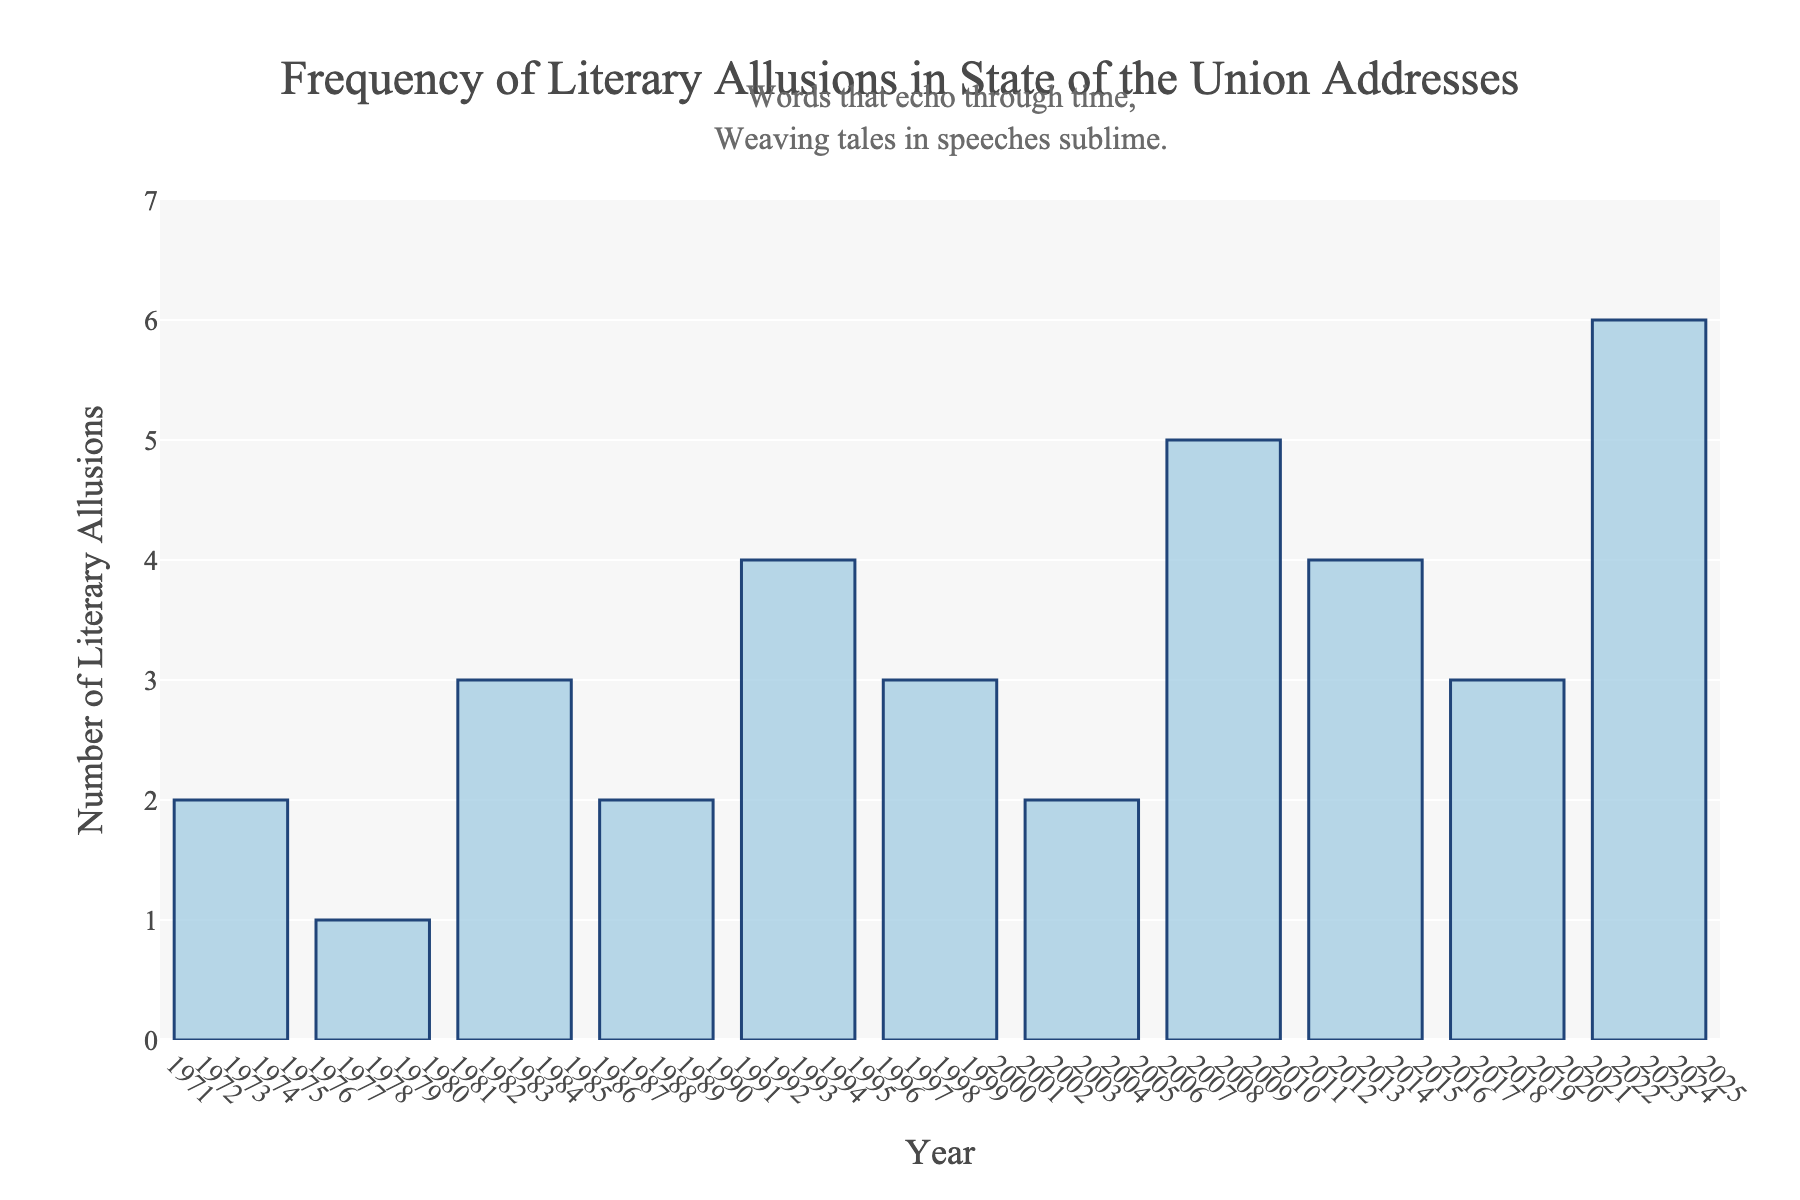Which year had the highest number of literary allusions? The bar corresponding to the year 2023 extends the highest on the y-axis at a value of 6, indicating the highest number of literary allusions.
Answer: 2023 How many literary allusions were made from 1993 to 2003 inclusive? Summing the number of allusions for the years 1993, 1998, and 2003 gives 4 + 3 + 2 = 9.
Answer: 9 Compare the number of literary allusions in 2008 and 2018. Which year had more? The height of the bar for 2008 is 5, while for 2018 it is 3. Since 5 is greater than 3, 2008 had more allusions.
Answer: 2008 What is the difference in the number of literary allusions between 1988 and 2008? The number of allusions in 1988 is 2 and in 2008 is 5. The difference is 5 - 2 = 3.
Answer: 3 Which years have exactly 3 literary allusions? The bars for the years 1983, 1998, and 2018 extend to the value of 3 on the y-axis.
Answer: 1983, 1998, 2018 What is the average number of literary allusions for the years shown? Summing all the allusions (2+1+3+2+4+3+2+5+4+3+6=35) and dividing by the number of years (11) gives an average of 35/11 ≈ 3.18.
Answer: 3.18 Is there an increasing or decreasing trend in literary allusions from 2003 to 2023? From 2003 (2 allusions) to 2008 (5 allusions) to 2013 (4 allusions) to 2018 (3 allusions) to 2023 (6 allusions), the numbers fluctuate but show an overall increasing trend.
Answer: Increasing How many more allusions were made in 2023 compared to 1973? There were 6 allusions in 2023 and 2 in 1973. The difference is 6 - 2 = 4.
Answer: 4 Does the year with the second highest number of literary allusions have more or less than half of the 2023 allusions? The year with the second highest number of allusions is 2008 with 5. Half of 2023's allusions (6/2) is 3, so 5 is greater than 3.
Answer: More 